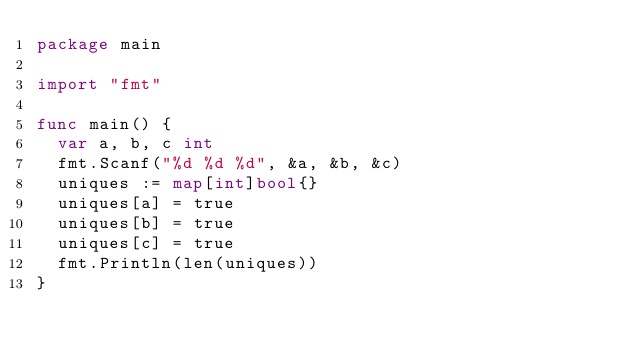<code> <loc_0><loc_0><loc_500><loc_500><_Go_>package main

import "fmt"

func main() {
	var a, b, c int
	fmt.Scanf("%d %d %d", &a, &b, &c)
	uniques := map[int]bool{}
	uniques[a] = true
	uniques[b] = true
	uniques[c] = true
	fmt.Println(len(uniques))
}
</code> 